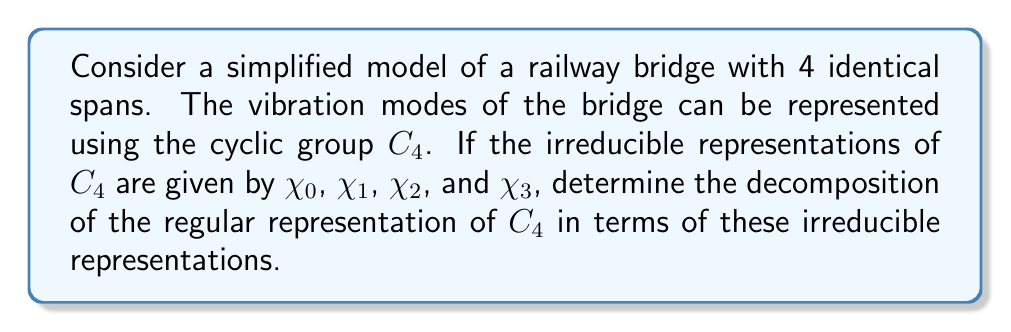Could you help me with this problem? Let's approach this step-by-step:

1) The cyclic group $C_4$ has 4 elements: $\{e, r, r^2, r^3\}$, where $e$ is the identity and $r$ is a rotation by 90°.

2) The character table for $C_4$ is:

   $$\begin{array}{c|cccc}
      & e & r & r^2 & r^3 \\
   \hline
   \chi_0 & 1 & 1 & 1 & 1 \\
   \chi_1 & 1 & i & -1 & -i \\
   \chi_2 & 1 & -1 & 1 & -1 \\
   \chi_3 & 1 & -i & -1 & i
   \end{array}$$

3) The regular representation $R$ has character values:
   $$\chi_R(e) = 4, \chi_R(r) = \chi_R(r^2) = \chi_R(r^3) = 0$$

4) To decompose $R$, we use the formula:
   $$n_i = \frac{1}{|G|} \sum_{g \in G} \chi_R(g) \overline{\chi_i(g)}$$
   where $n_i$ is the number of times the irreducible representation $\chi_i$ appears in $R$.

5) Calculating for each $\chi_i$:

   For $\chi_0$: $n_0 = \frac{1}{4}(4 \cdot 1 + 0 \cdot 1 + 0 \cdot 1 + 0 \cdot 1) = 1$
   
   For $\chi_1$: $n_1 = \frac{1}{4}(4 \cdot 1 + 0 \cdot (-i) + 0 \cdot (-1) + 0 \cdot i) = 1$
   
   For $\chi_2$: $n_2 = \frac{1}{4}(4 \cdot 1 + 0 \cdot (-1) + 0 \cdot 1 + 0 \cdot (-1)) = 1$
   
   For $\chi_3$: $n_3 = \frac{1}{4}(4 \cdot 1 + 0 \cdot i + 0 \cdot (-1) + 0 \cdot (-i)) = 1$

6) Therefore, the regular representation $R$ decomposes as:
   $$R = \chi_0 \oplus \chi_1 \oplus \chi_2 \oplus \chi_3$$
Answer: $R = \chi_0 \oplus \chi_1 \oplus \chi_2 \oplus \chi_3$ 